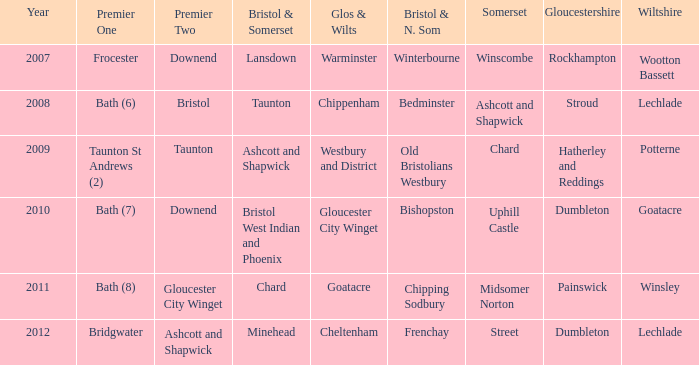What is the bristol & n. som where the somerset is ashcott and shapwick? Bedminster. 